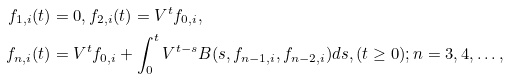Convert formula to latex. <formula><loc_0><loc_0><loc_500><loc_500>f _ { 1 , i } ( t ) & = 0 , f _ { 2 , i } ( t ) = V ^ { t } f _ { 0 , i } , \\ f _ { n , i } ( t ) & = V ^ { t } f _ { 0 , i } + \int _ { 0 } ^ { t } V ^ { t - s } B ( s , f _ { n - 1 , i } , f _ { n - 2 , i } ) d s , ( t \geq 0 ) ; n = 3 , 4 , \dots ,</formula> 